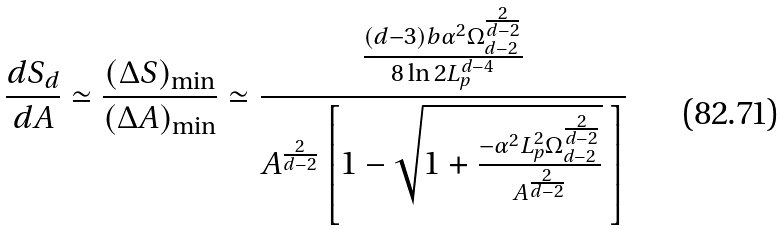<formula> <loc_0><loc_0><loc_500><loc_500>\frac { d S _ { d } } { d A } \simeq \frac { ( \Delta S ) _ { \min } } { ( \Delta A ) _ { \min } } \simeq \frac { \frac { ( d - 3 ) b \alpha ^ { 2 } \Omega _ { d - 2 } ^ { \frac { 2 } { d - 2 } } } { 8 \ln 2 L _ { p } ^ { d - 4 } } } { A ^ { \frac { 2 } { d - 2 } } \left [ 1 - \sqrt { 1 + \frac { - \alpha ^ { 2 } L _ { p } ^ { 2 } \Omega _ { d - 2 } ^ { \frac { 2 } { d - 2 } } } { A ^ { \frac { 2 } { d - 2 } } } } \ \right ] }</formula> 